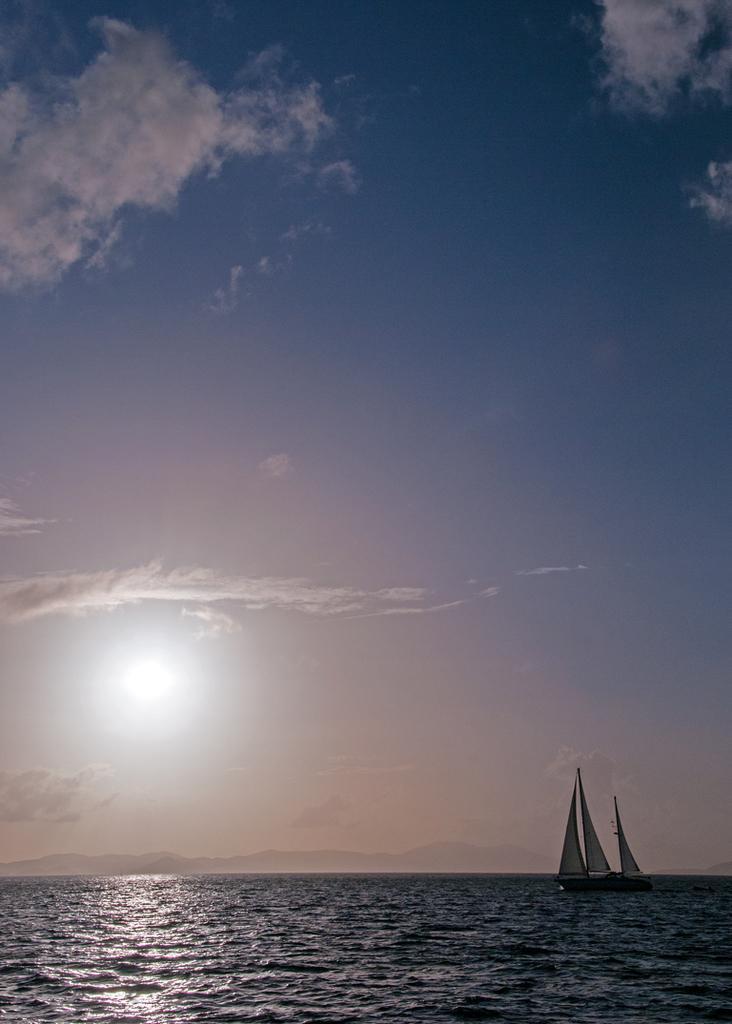Can you describe this image briefly? In this image we can see a sea. There are few hills in the image. There is a slightly cloudy sky in the image. There is a sun in the image. There are few water crafts on the sea surface in the image. 